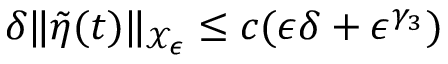<formula> <loc_0><loc_0><loc_500><loc_500>\delta \| \tilde { \eta } ( t ) \| _ { \mathcal { X } _ { \epsilon } } \leq c ( \epsilon \delta + \epsilon ^ { \gamma _ { 3 } } )</formula> 